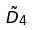<formula> <loc_0><loc_0><loc_500><loc_500>\tilde { D } _ { 4 }</formula> 